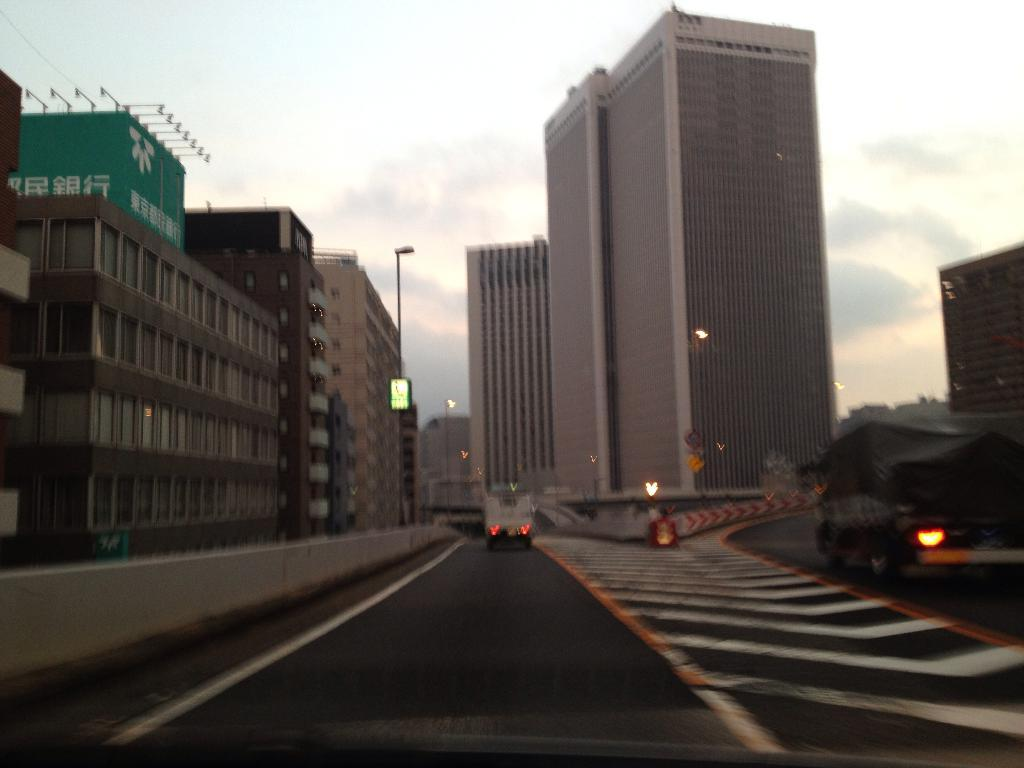What is the main feature in the center of the image? There is a road in the center of the image. What is happening on the road? There are vehicles on the road. What can be seen in the background of the image? There are buildings and a pole in the background of the image. What is visible at the top of the image? The sky is visible at the top of the image. What type of form does the quiver take in the image? There is no quiver present in the image. How does the control system work in the image? There is no control system present in the image. 